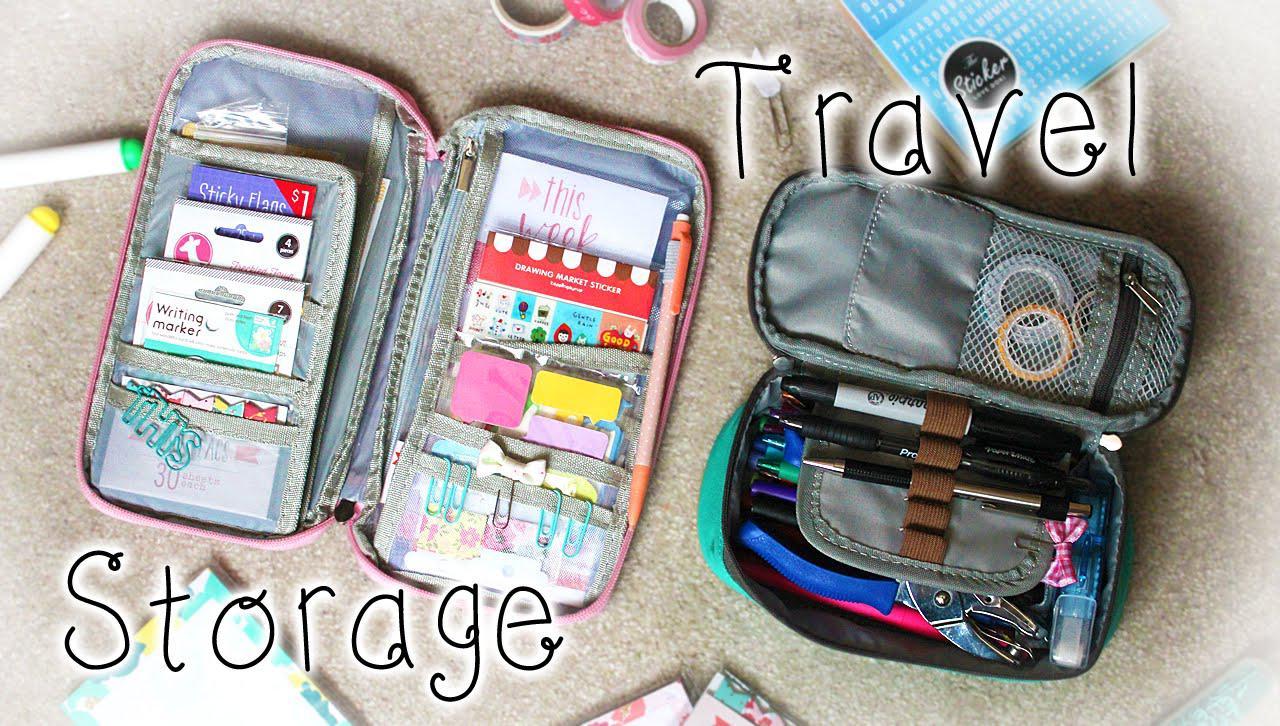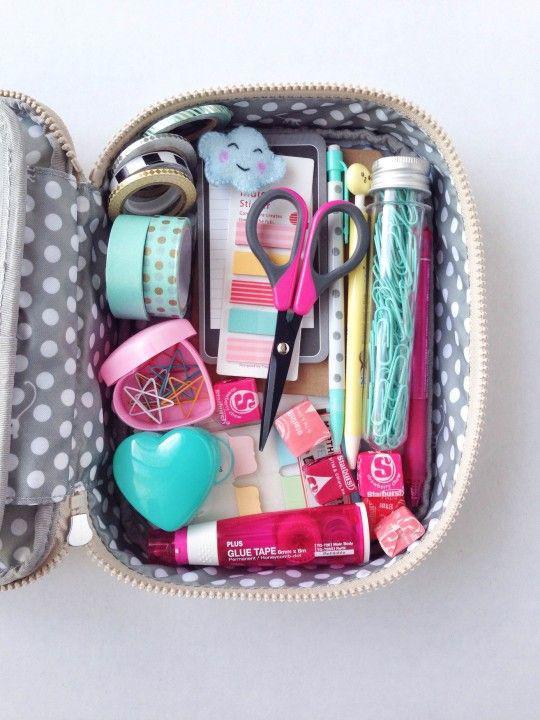The first image is the image on the left, the second image is the image on the right. Given the left and right images, does the statement "The right image depicts at least three pencil cases." hold true? Answer yes or no. No. 